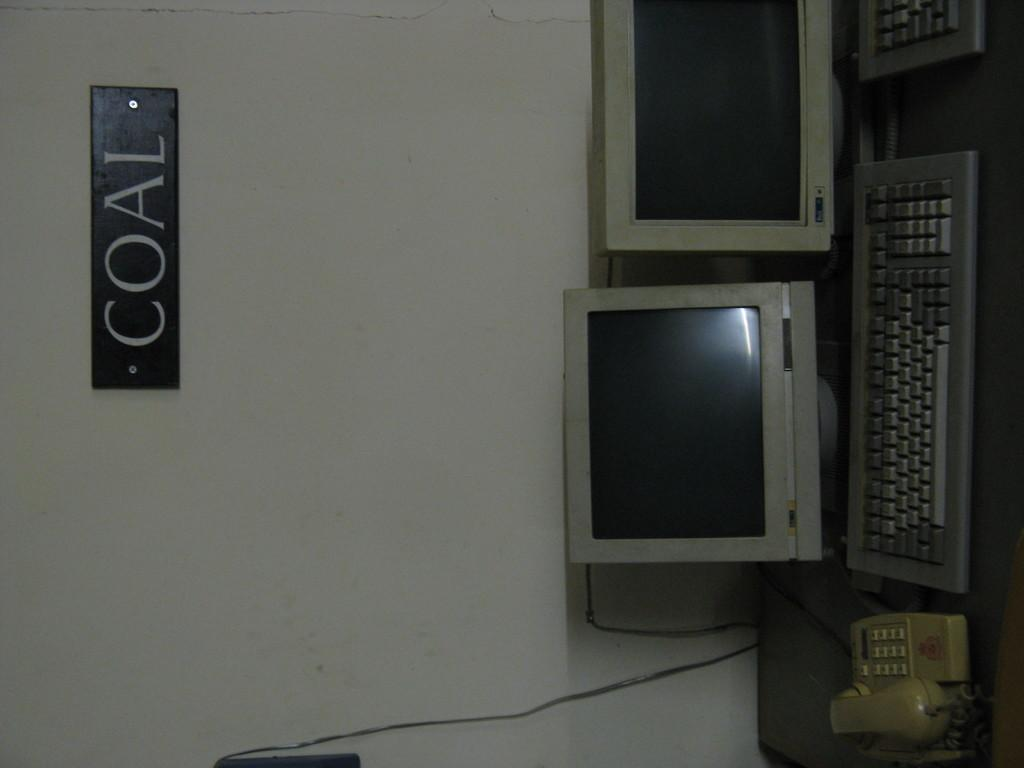<image>
Relay a brief, clear account of the picture shown. Above two old monitors is a sign with the word COAL. 